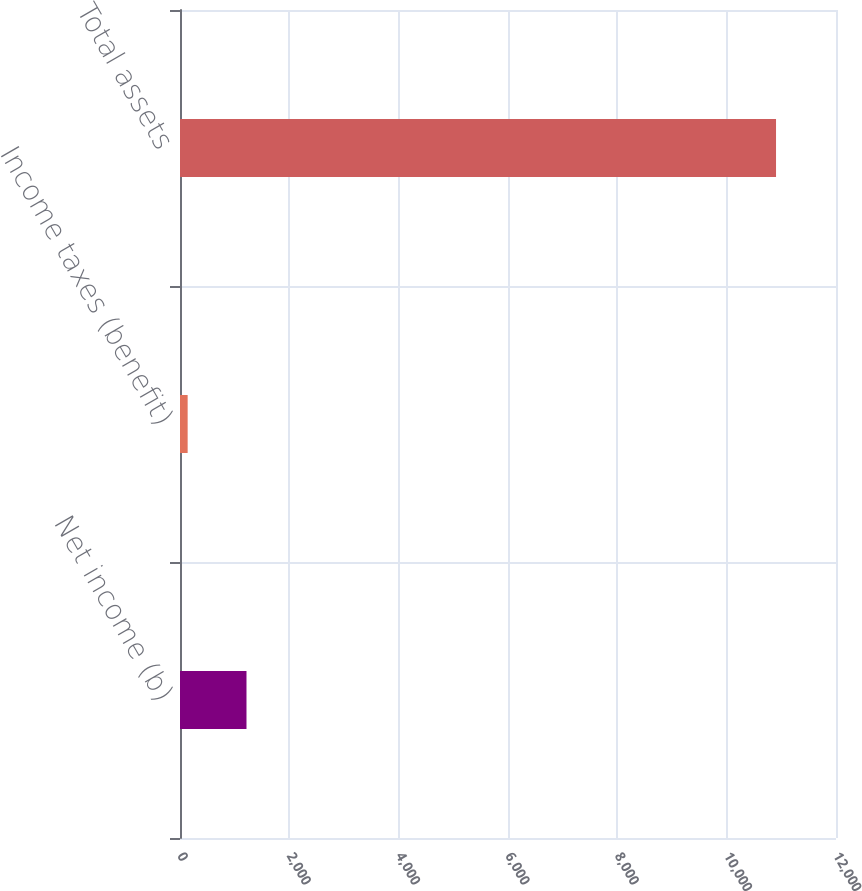<chart> <loc_0><loc_0><loc_500><loc_500><bar_chart><fcel>Net income (b)<fcel>Income taxes (benefit)<fcel>Total assets<nl><fcel>1216.3<fcel>140<fcel>10903<nl></chart> 